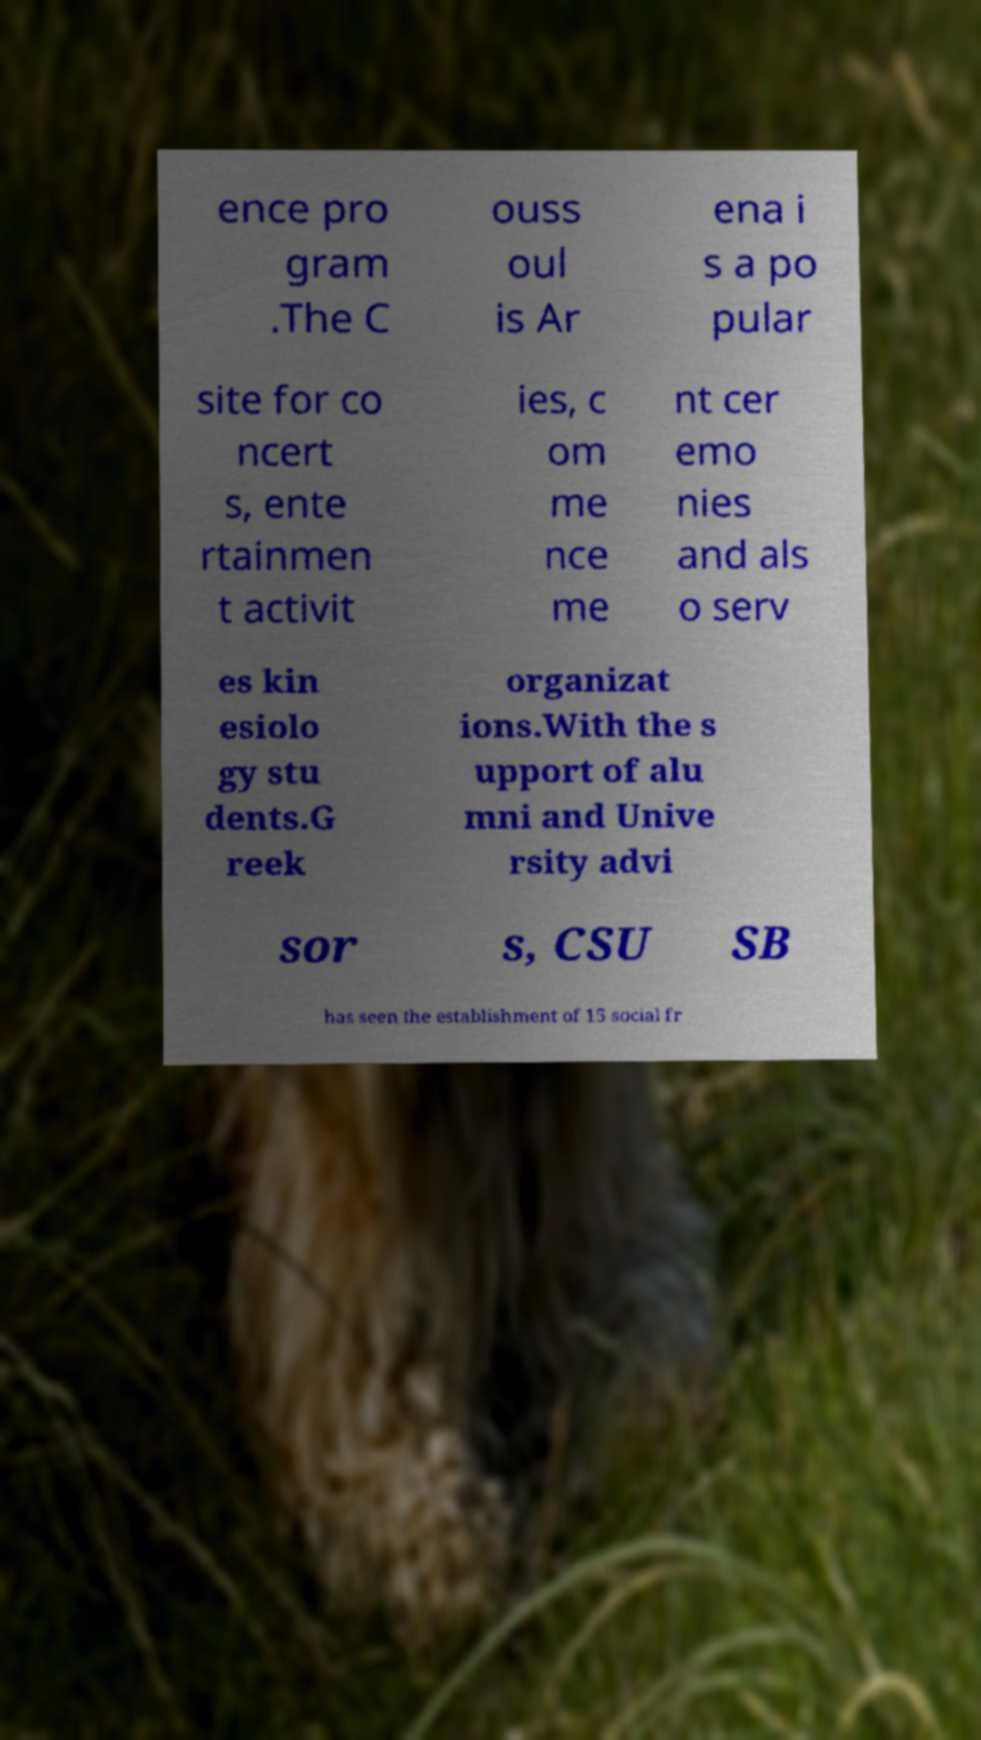There's text embedded in this image that I need extracted. Can you transcribe it verbatim? ence pro gram .The C ouss oul is Ar ena i s a po pular site for co ncert s, ente rtainmen t activit ies, c om me nce me nt cer emo nies and als o serv es kin esiolo gy stu dents.G reek organizat ions.With the s upport of alu mni and Unive rsity advi sor s, CSU SB has seen the establishment of 15 social fr 